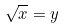<formula> <loc_0><loc_0><loc_500><loc_500>\sqrt { x } = y</formula> 